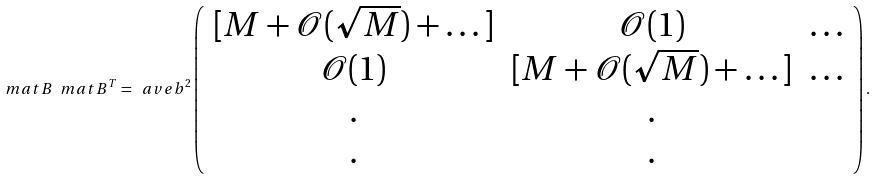<formula> <loc_0><loc_0><loc_500><loc_500>\ m a t { B } \ m a t { B } ^ { T } = \ a v e { b ^ { 2 } } \left ( \begin{array} { c c c } [ M + { \mathcal { O } } ( \sqrt { M } ) + \dots ] & { \mathcal { O } } ( 1 ) & \dots \\ { \mathcal { O } } ( 1 ) & [ M + { \mathcal { O } } ( \sqrt { M } ) + \dots ] & \dots \\ . & . \\ . & . \end{array} \right ) .</formula> 